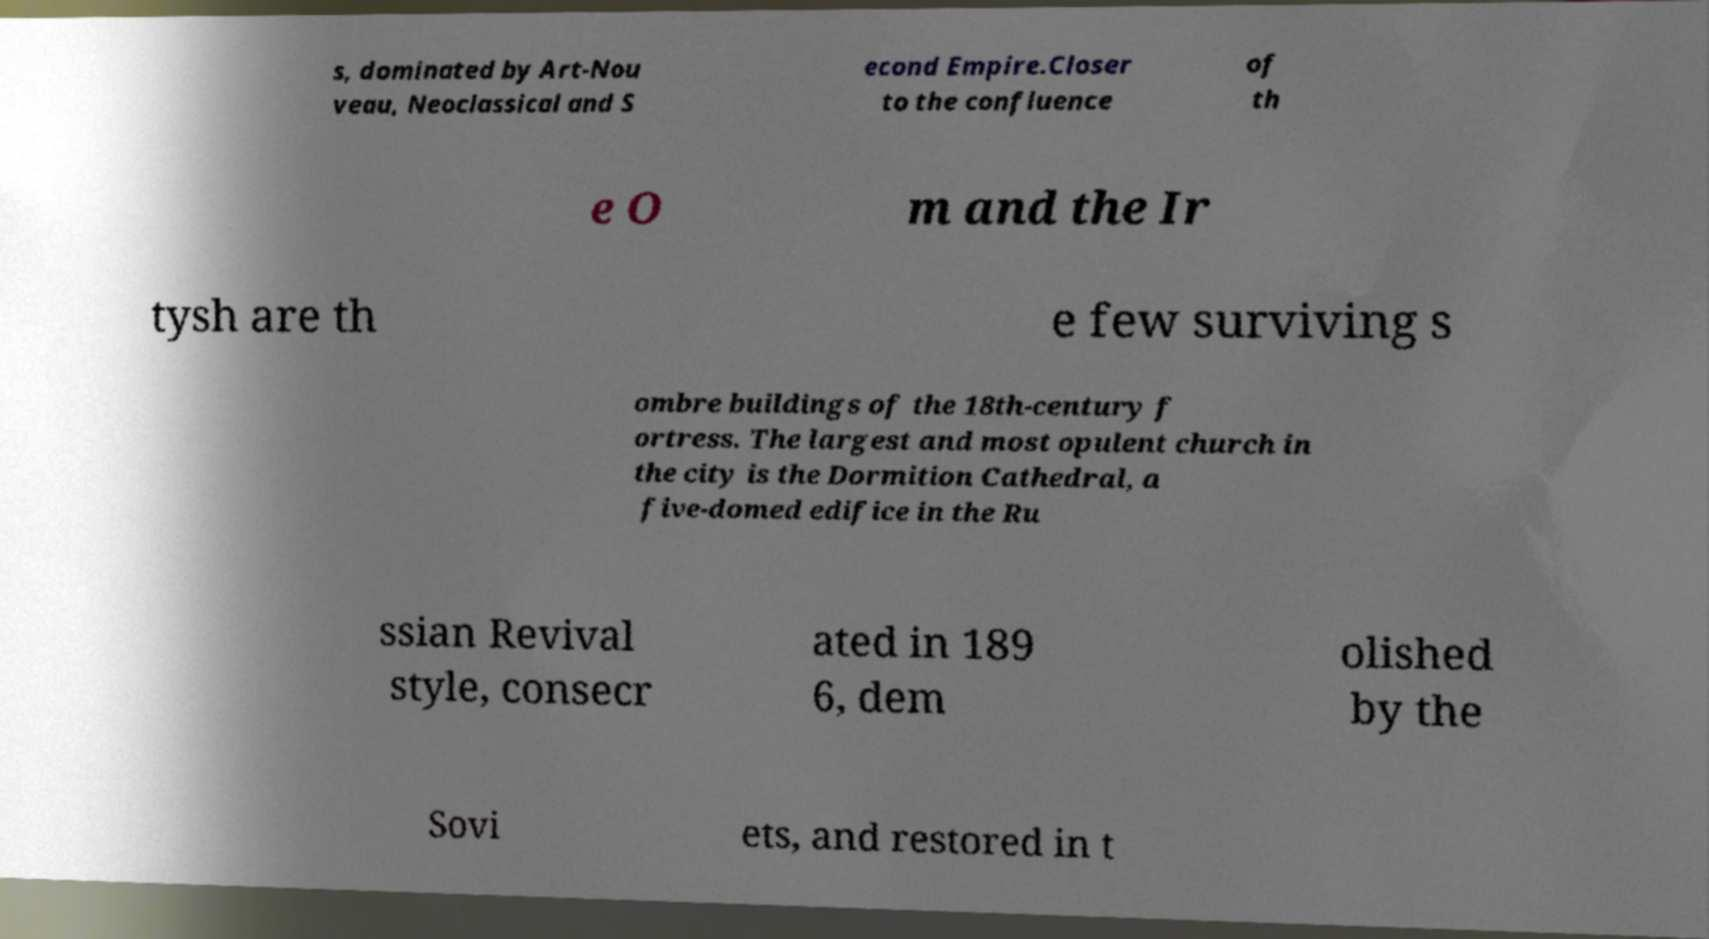Could you extract and type out the text from this image? s, dominated by Art-Nou veau, Neoclassical and S econd Empire.Closer to the confluence of th e O m and the Ir tysh are th e few surviving s ombre buildings of the 18th-century f ortress. The largest and most opulent church in the city is the Dormition Cathedral, a five-domed edifice in the Ru ssian Revival style, consecr ated in 189 6, dem olished by the Sovi ets, and restored in t 